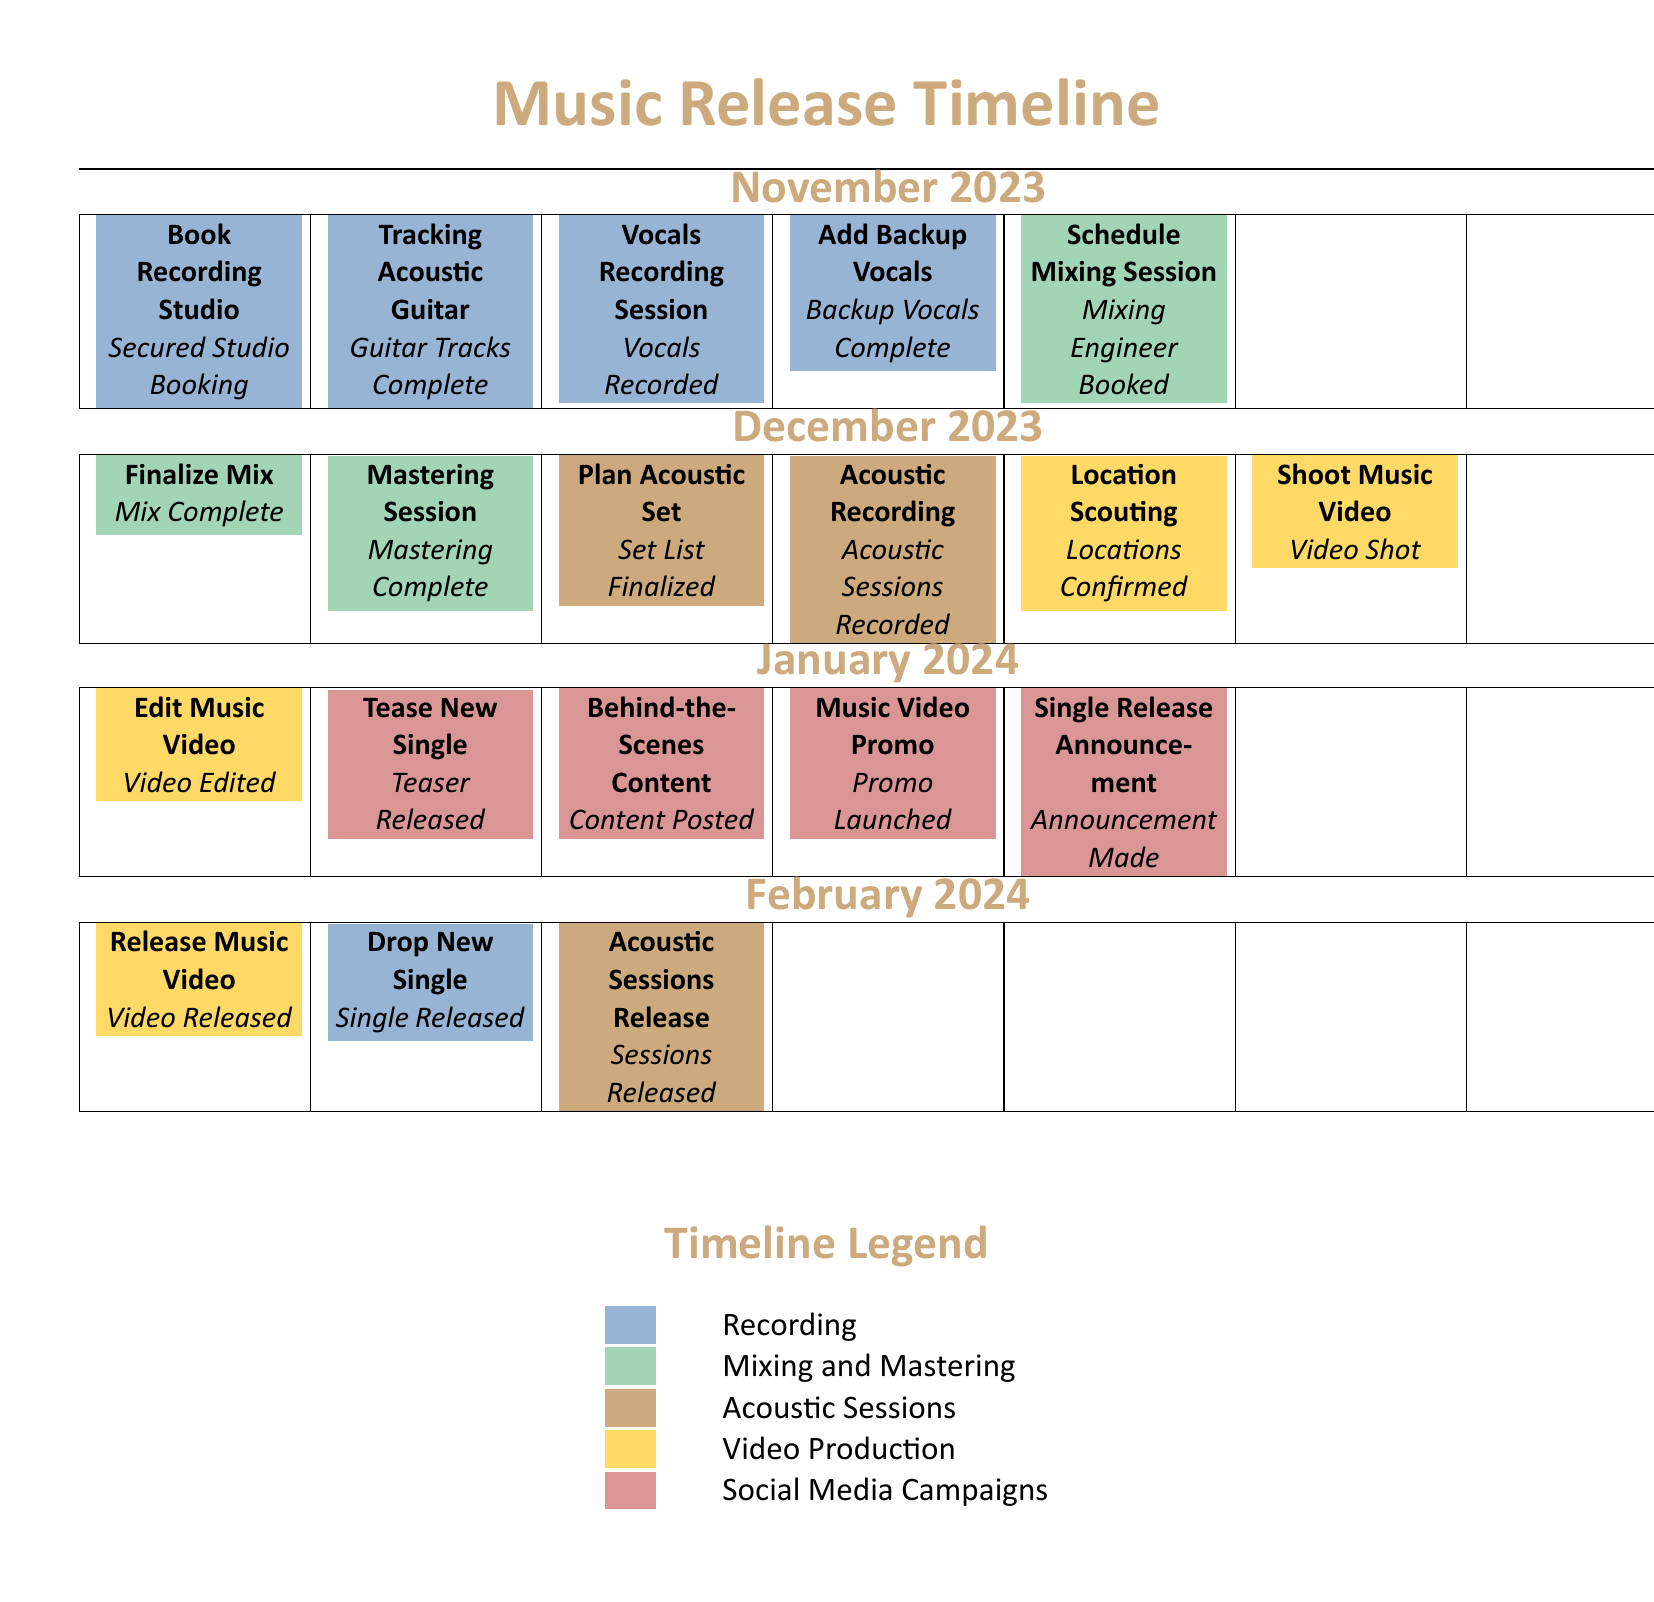What is the first task in November 2023? The first task listed in November 2023 is "Book Recording Studio".
Answer: Book Recording Studio How many tasks are scheduled for December 2023? There are five tasks scheduled for December 2023 as listed in the document.
Answer: 5 What milestone is scheduled for January 2024? A significant milestone in January 2024 is the "Single Release Announcement".
Answer: Single Release Announcement What color indicates Acoustic Sessions in the document? The color that indicates Acoustic Sessions is a shade represented by the RGB values (205,170,125).
Answer: Acoustic When is the Drop New Single scheduled for release? The document indicates that the Drop New Single is scheduled for release in February 2024.
Answer: February 2024 What task follows the "Editing Music Video" task in January 2024? Following the "Edit Music Video" task is the "Tease New Single" task in January 2024.
Answer: Tease New Single What is the deadline for "Finalize Mix"? The deadline for "Finalize Mix" is the end of December 2023 as indicated in the timeline.
Answer: December 2023 What is the color code for Video Production tasks? Video Production tasks in the document are represented in a color corresponding to the RGB values (255,217,102).
Answer: Video Production 